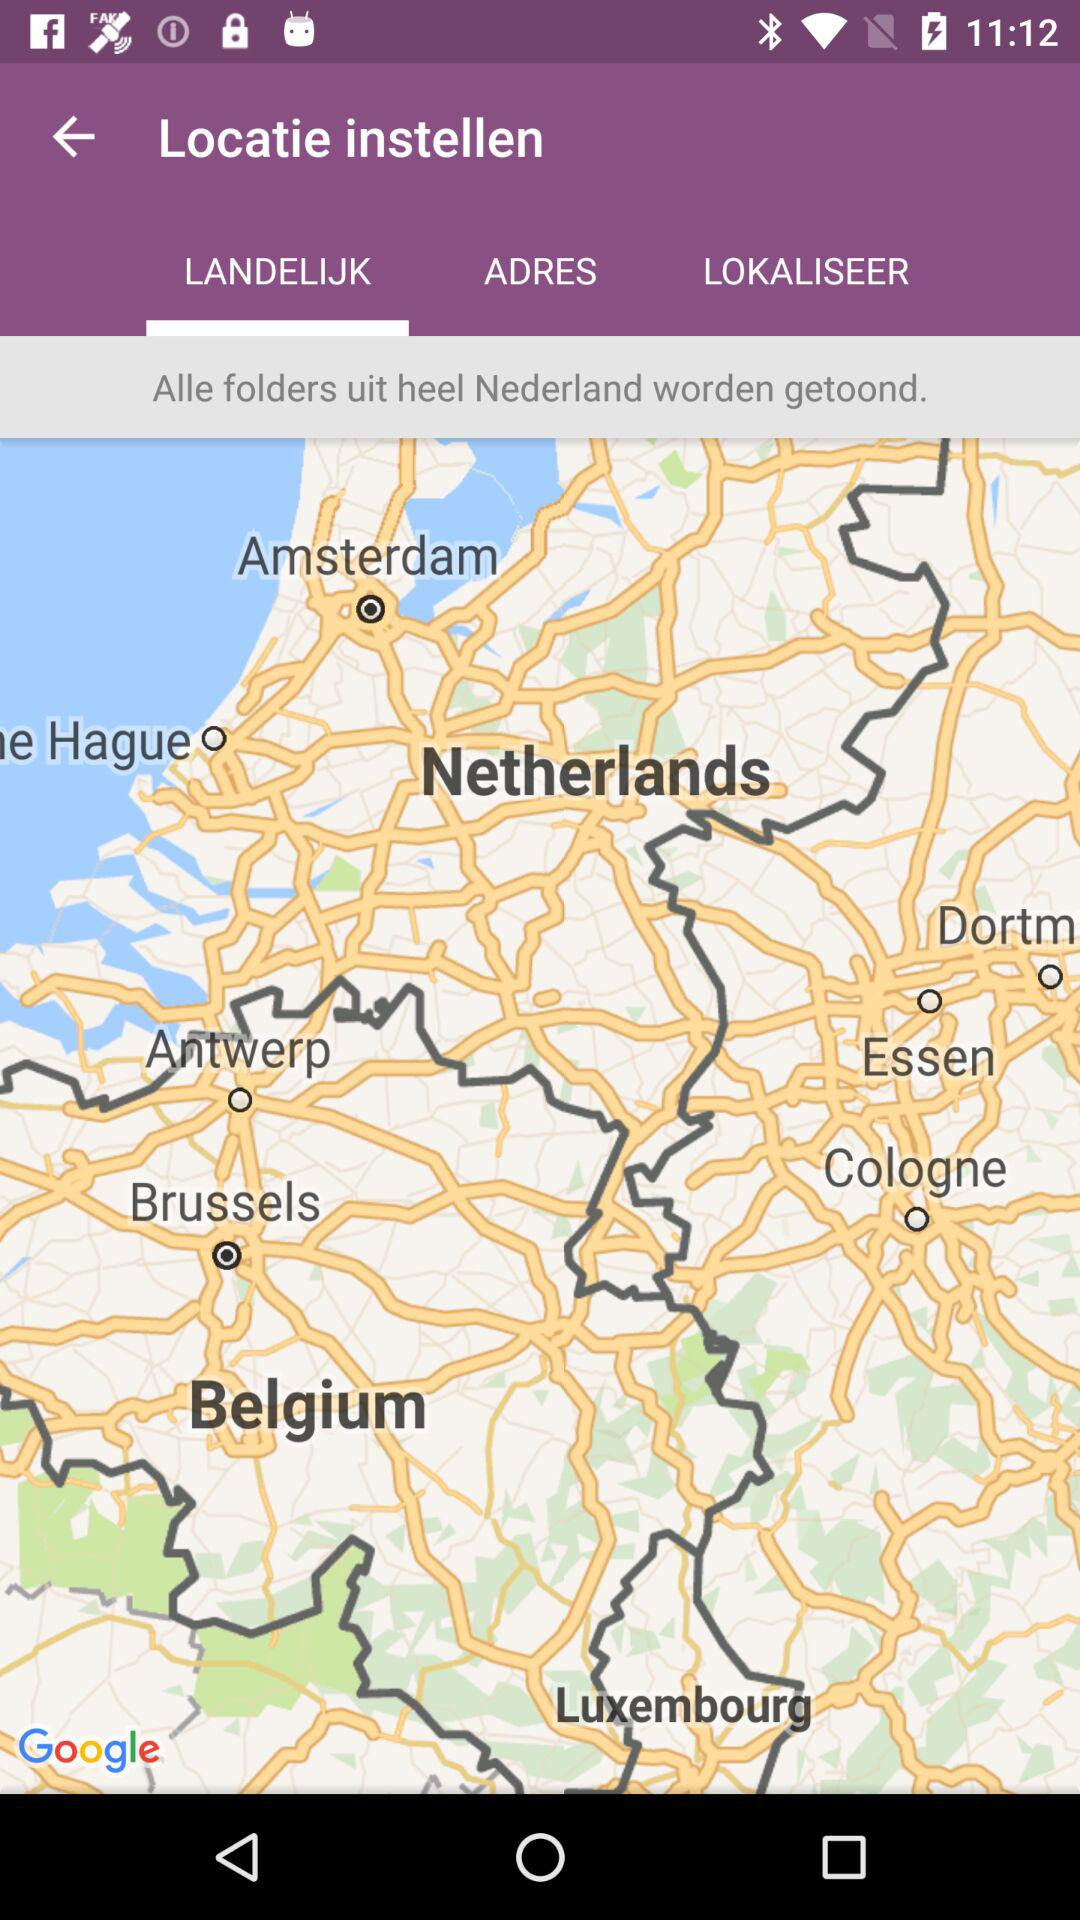Which tab is selected? The selected tab is "LANDELIJK". 